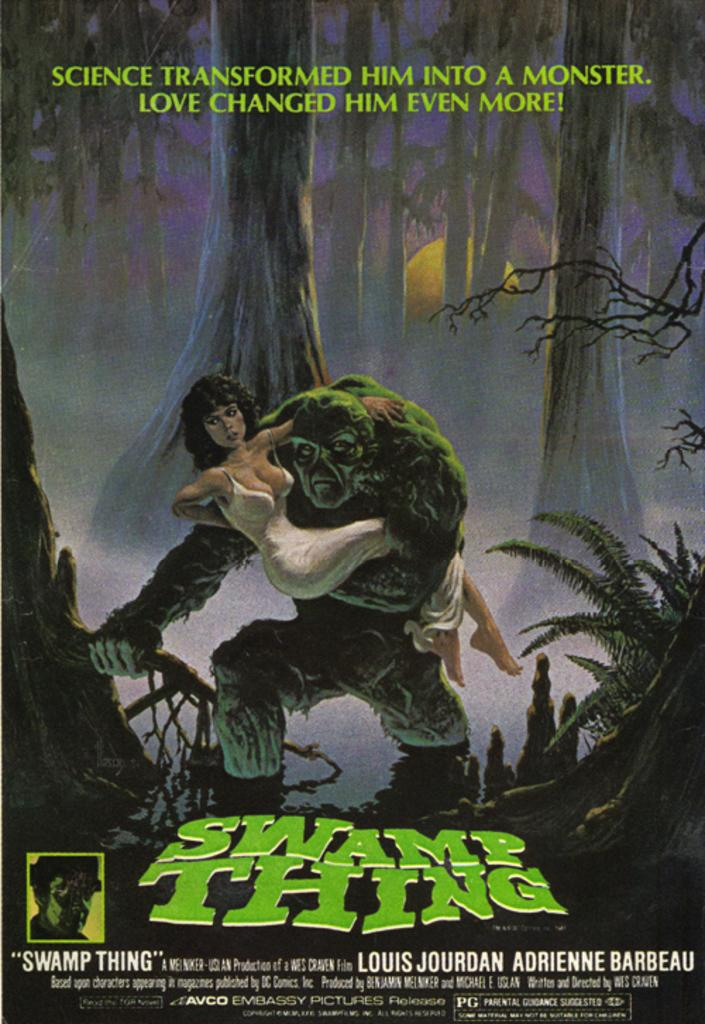<image>
Summarize the visual content of the image. A poster for Swamp Thing shows the creature wading through a swamp with a woman cradled in its arms. 